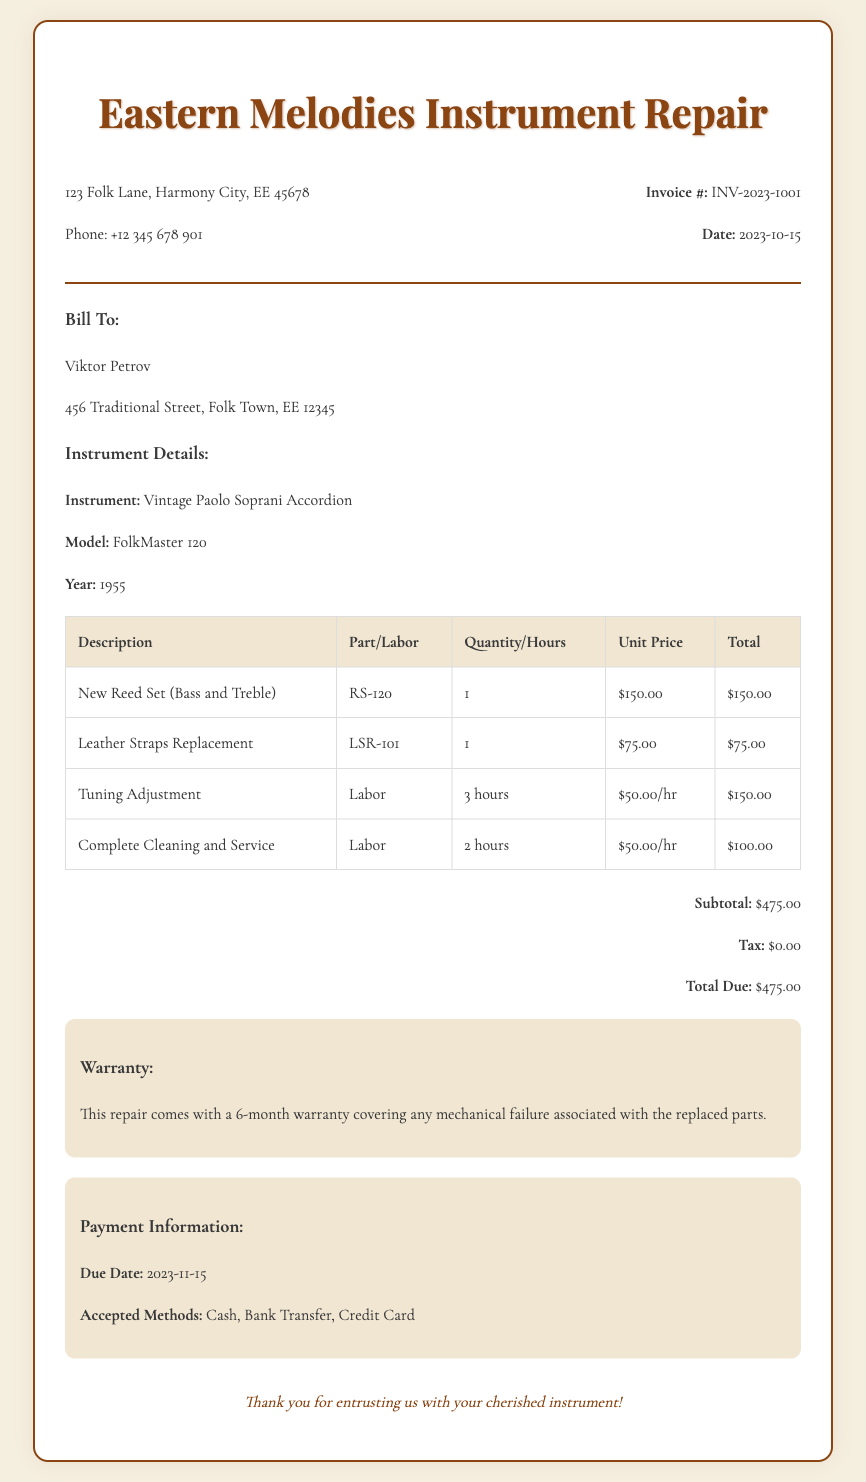What is the invoice number? The invoice number is clearly listed in the document under the invoice details section as INV-2023-1001.
Answer: INV-2023-1001 Who is the client? The client's name is provided at the top of the bill under the "Bill To:" section, which is Viktor Petrov.
Answer: Viktor Petrov What is the total due amount? The total due amount is indicated at the bottom of the summary section, which sums up all charges and taxes.
Answer: $475.00 How many hours were spent on Tuning Adjustment? The Tuning Adjustment labor entry specifies that it took 3 hours to complete.
Answer: 3 hours What year was the Vintage Paolo Soprani Accordion made? The year of manufacture is mentioned in the instrument details section, which states 1955.
Answer: 1955 Is there a warranty on the repair? The document specifies a warranty in the warranty section, indicating that there is coverage on the repair.
Answer: Yes How much does the leather straps replacement cost? The cost is detailed in the table as $75.00 for the leather straps replacement.
Answer: $75.00 What is the due date for payment? The due date for payment is mentioned in the payment information section as 2023-11-15.
Answer: 2023-11-15 How many total hours of labor were provided? By adding the hours for Tuning Adjustment and Complete Cleaning and Service, we get 3 + 2 hours of labor, leading to a total.
Answer: 5 hours 